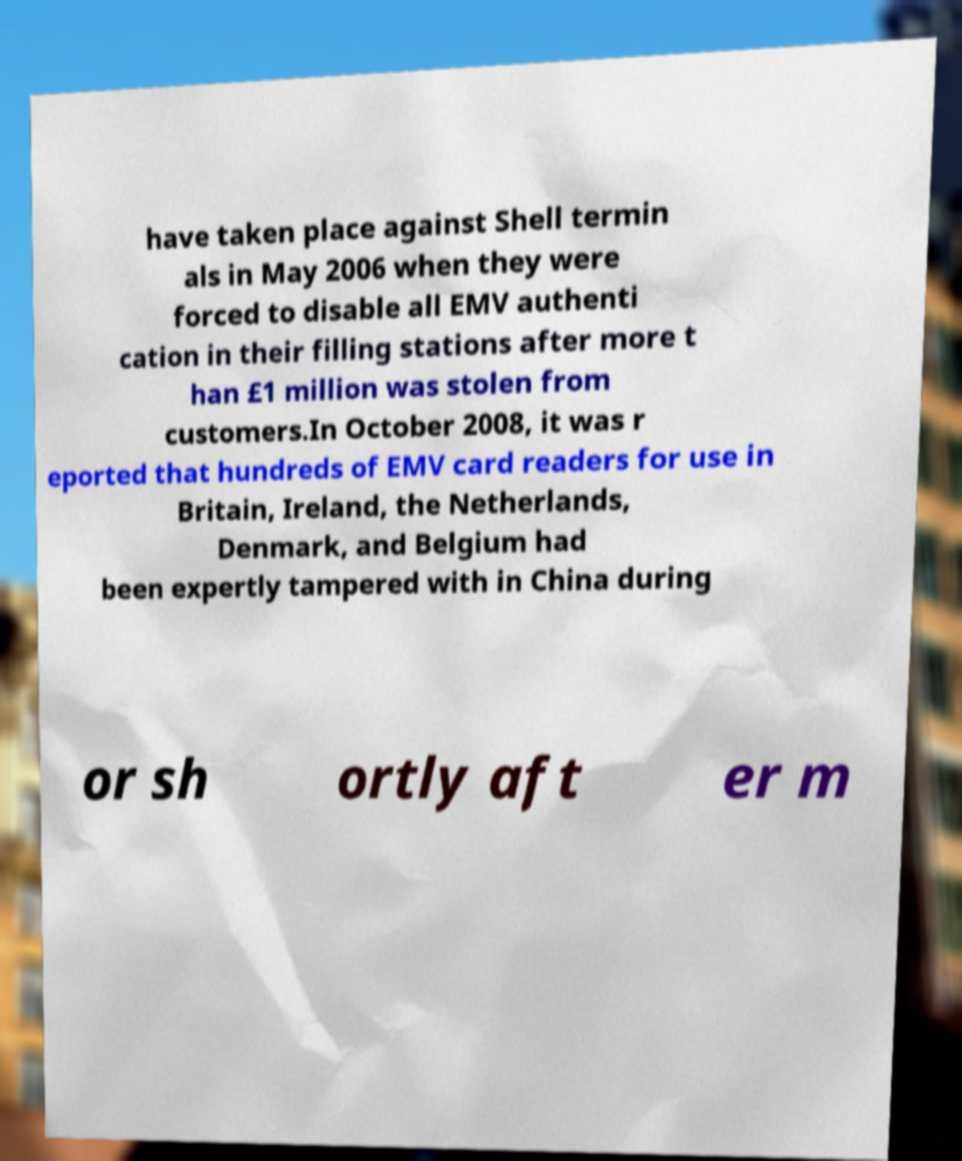Please identify and transcribe the text found in this image. have taken place against Shell termin als in May 2006 when they were forced to disable all EMV authenti cation in their filling stations after more t han £1 million was stolen from customers.In October 2008, it was r eported that hundreds of EMV card readers for use in Britain, Ireland, the Netherlands, Denmark, and Belgium had been expertly tampered with in China during or sh ortly aft er m 